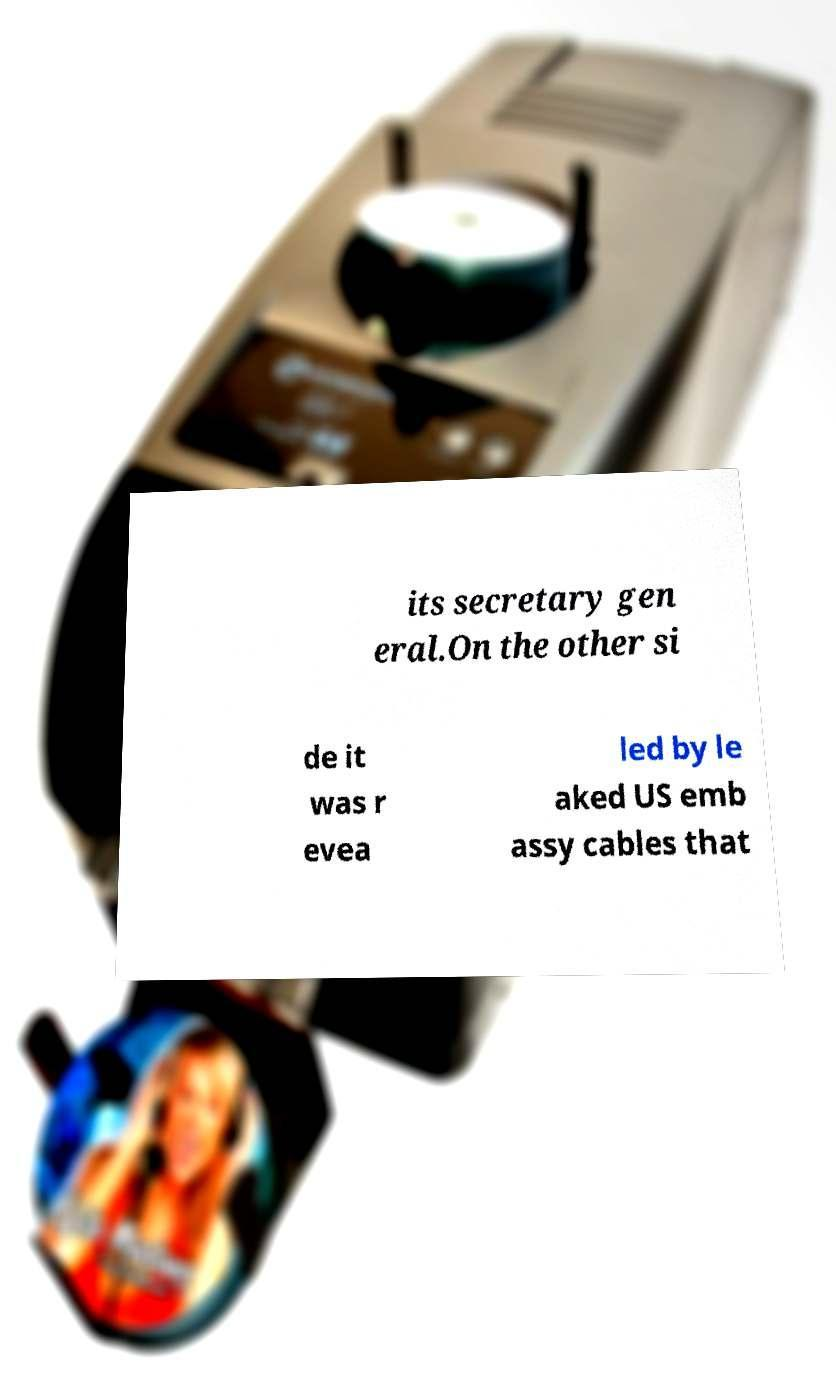Could you assist in decoding the text presented in this image and type it out clearly? its secretary gen eral.On the other si de it was r evea led by le aked US emb assy cables that 